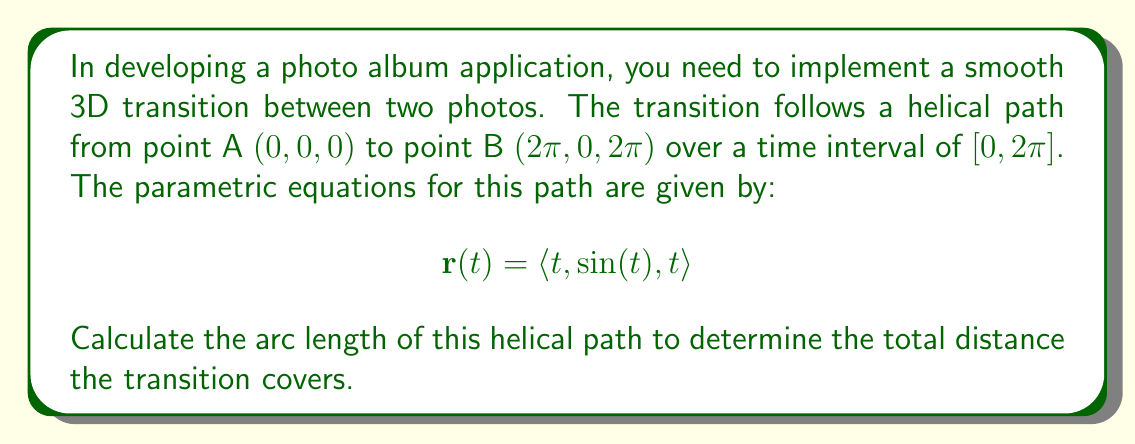Can you solve this math problem? To calculate the arc length of the helical path, we need to follow these steps:

1) The arc length of a curve defined by a vector-valued function $\mathbf{r}(t)$ over an interval $[a, b]$ is given by:

   $$L = \int_a^b |\mathbf{r}'(t)| dt$$

2) First, we need to find $\mathbf{r}'(t)$:
   
   $$\mathbf{r}'(t) = \langle 1, \cos(t), 1 \rangle$$

3) Now, we calculate $|\mathbf{r}'(t)|$:
   
   $$|\mathbf{r}'(t)| = \sqrt{1^2 + \cos^2(t) + 1^2} = \sqrt{2 + \cos^2(t)}$$

4) Our integral becomes:

   $$L = \int_0^{2\pi} \sqrt{2 + \cos^2(t)} dt$$

5) This integral doesn't have an elementary antiderivative. We can solve it using the following substitution:

   Let $\cos(t) = \sqrt{2}\sin(u)$, then $dt = \frac{\sqrt{2}\cos(u)}{\sqrt{1-2\sin^2(u)}}du$

6) After substitution and simplification, we get:

   $$L = 2\sqrt{2}\int_0^{\pi/2} \sqrt{1-\sin^2(u)}du = 2\sqrt{2}\int_0^{\pi/2} \cos(u)du$$

7) Evaluating this integral:

   $$L = 2\sqrt{2}[\sin(u)]_0^{\pi/2} = 2\sqrt{2}$$

Therefore, the arc length of the helical path is $2\sqrt{2}\pi$.
Answer: $2\sqrt{2}\pi$ 